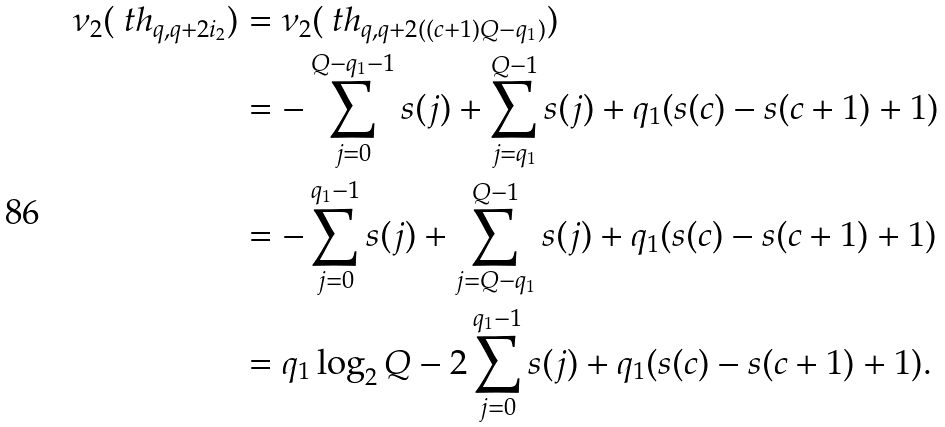Convert formula to latex. <formula><loc_0><loc_0><loc_500><loc_500>\nu _ { 2 } ( \ t h _ { q , q + 2 i _ { 2 } } ) & = \nu _ { 2 } ( \ t h _ { q , q + 2 ( ( c + 1 ) Q - q _ { 1 } ) } ) \\ & = - \sum _ { j = 0 } ^ { Q - q _ { 1 } - 1 } s ( j ) + \sum _ { j = q _ { 1 } } ^ { Q - 1 } s ( j ) + q _ { 1 } ( s ( c ) - s ( c + 1 ) + 1 ) \\ & = - \sum _ { j = 0 } ^ { q _ { 1 } - 1 } s ( j ) + \sum _ { j = Q - q _ { 1 } } ^ { Q - 1 } s ( j ) + q _ { 1 } ( s ( c ) - s ( c + 1 ) + 1 ) \\ & = q _ { 1 } \log _ { 2 } Q - 2 \sum _ { j = 0 } ^ { q _ { 1 } - 1 } s ( j ) + q _ { 1 } ( s ( c ) - s ( c + 1 ) + 1 ) .</formula> 